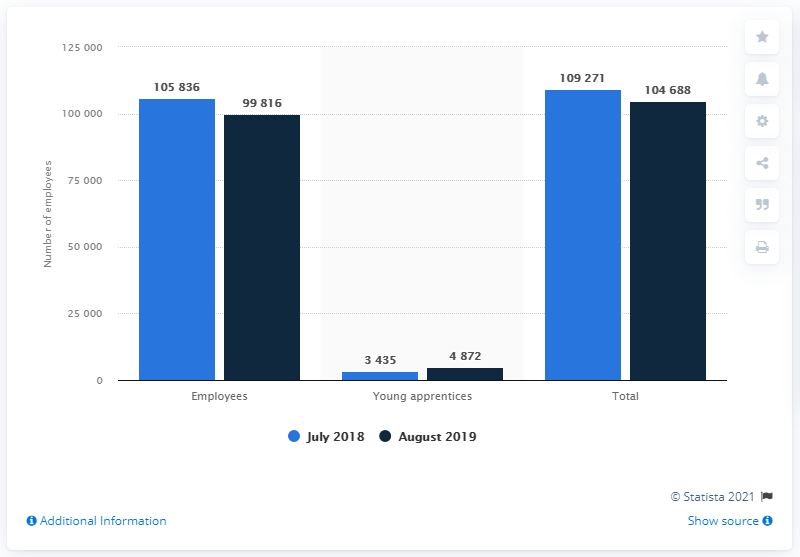Give some essential details in this illustration. In July 2018, the total workforce of Empresa Brasileira de Correios e Telégrafos was approximately 109,271 individuals. 